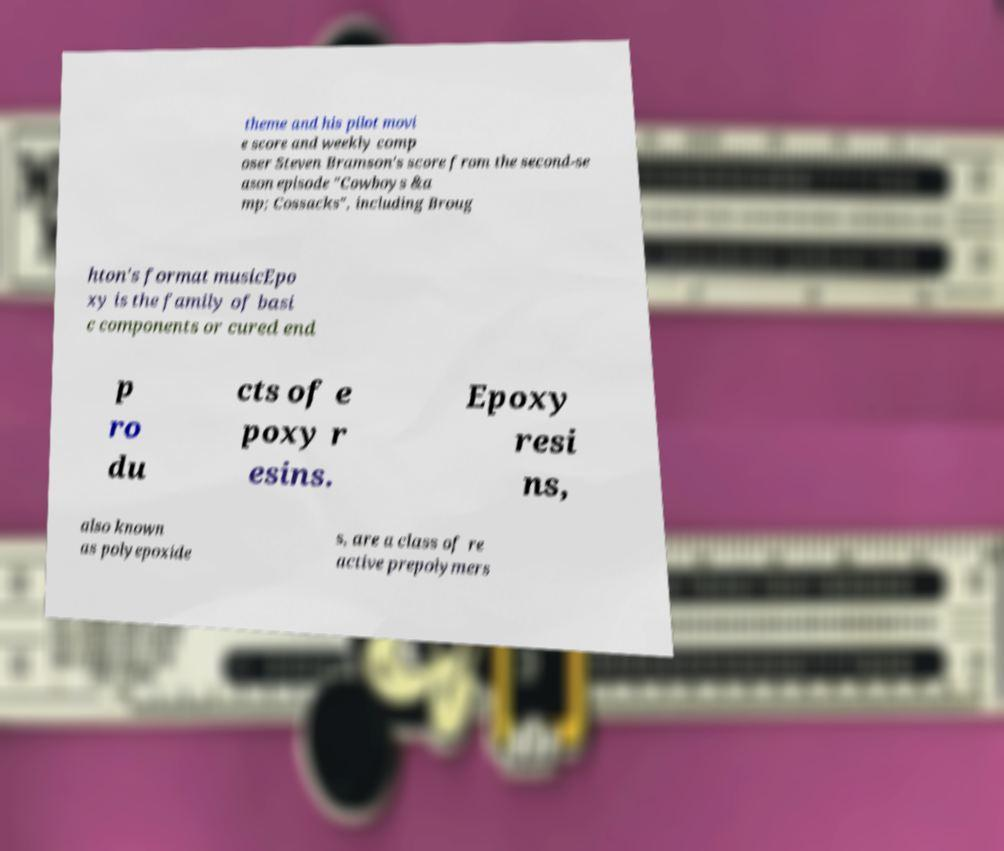Could you extract and type out the text from this image? theme and his pilot movi e score and weekly comp oser Steven Bramson's score from the second-se ason episode "Cowboys &a mp; Cossacks", including Broug hton's format musicEpo xy is the family of basi c components or cured end p ro du cts of e poxy r esins. Epoxy resi ns, also known as polyepoxide s, are a class of re active prepolymers 